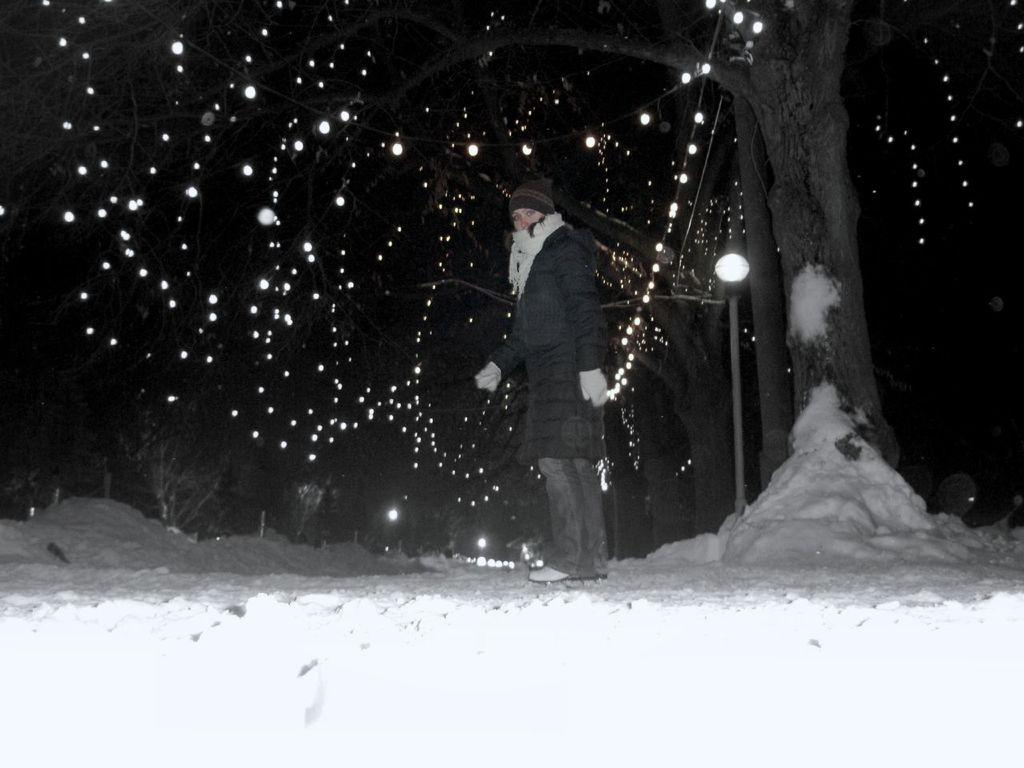What is the primary feature of the foreground in the image? There is snow in the foreground of the image. What is the person in the image doing? There is a person walking in the center of the image. What can be seen in the background of the image? There are lights, street lights, trees, and snow in the background of the image. What type of force is being applied by the person walking in the image? There is no indication of any force being applied by the person walking in the image. How does the verse relate to the image? There is no verse present in the image, so it cannot be related to the image. 